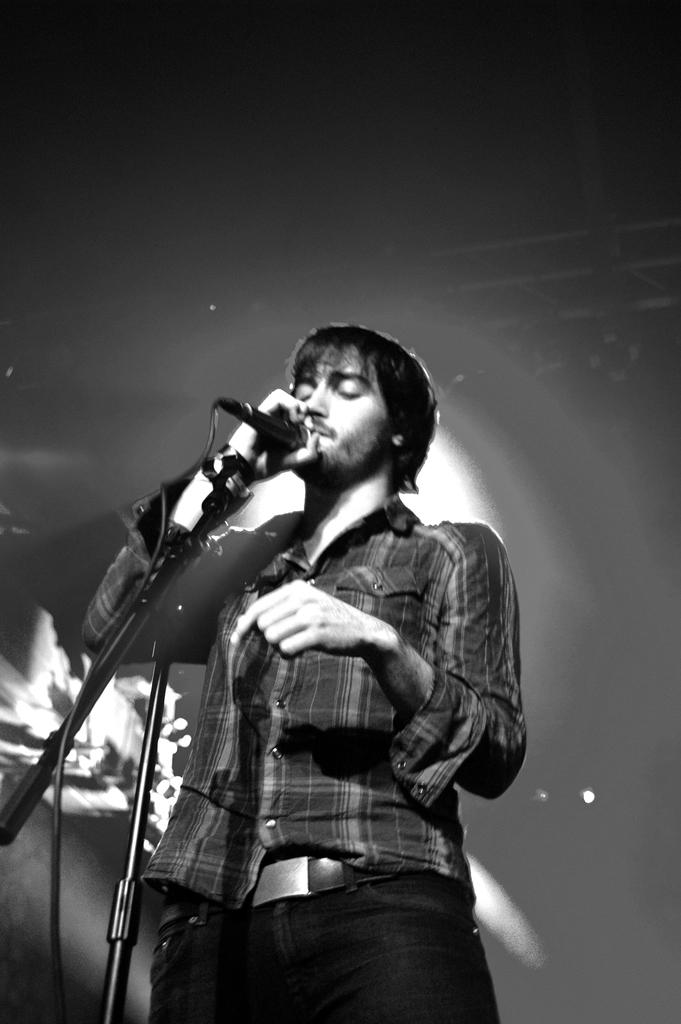What is the main subject of the image? The main subject of the image is a man. What is the man doing in the image? The man is standing and singing in the image. What object is the man holding in his hand? The man is holding a mic in his hand. What type of coal is being used to celebrate the man's birthday in the image? There is no coal or birthday celebration present in the image. What type of school is the man attending in the image? There is no school or indication of the man attending school in the image. 